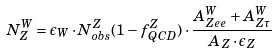Convert formula to latex. <formula><loc_0><loc_0><loc_500><loc_500>N ^ { W } _ { Z } = \epsilon _ { W } \cdot N _ { o b s } ^ { Z } ( 1 - f _ { Q C D } ^ { Z } ) \cdot \frac { A _ { Z e e } ^ { W } + A _ { Z \tau } ^ { W } } { A _ { Z } \cdot \epsilon _ { Z } }</formula> 